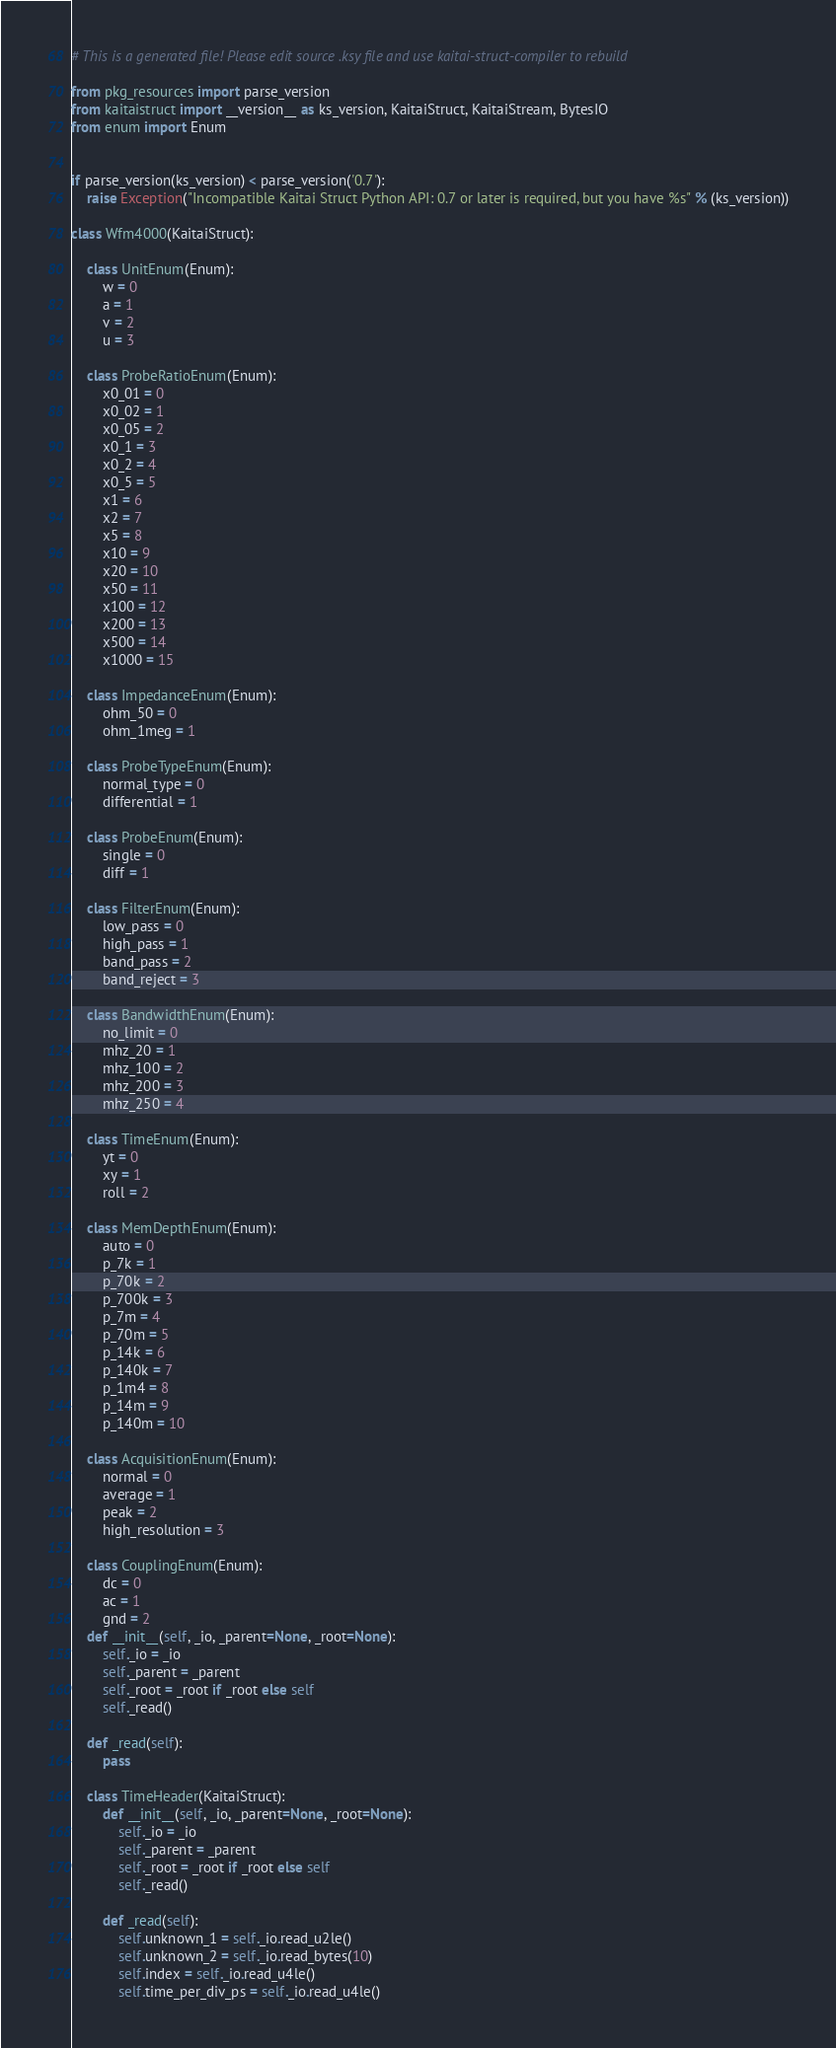<code> <loc_0><loc_0><loc_500><loc_500><_Python_># This is a generated file! Please edit source .ksy file and use kaitai-struct-compiler to rebuild

from pkg_resources import parse_version
from kaitaistruct import __version__ as ks_version, KaitaiStruct, KaitaiStream, BytesIO
from enum import Enum


if parse_version(ks_version) < parse_version('0.7'):
    raise Exception("Incompatible Kaitai Struct Python API: 0.7 or later is required, but you have %s" % (ks_version))

class Wfm4000(KaitaiStruct):

    class UnitEnum(Enum):
        w = 0
        a = 1
        v = 2
        u = 3

    class ProbeRatioEnum(Enum):
        x0_01 = 0
        x0_02 = 1
        x0_05 = 2
        x0_1 = 3
        x0_2 = 4
        x0_5 = 5
        x1 = 6
        x2 = 7
        x5 = 8
        x10 = 9
        x20 = 10
        x50 = 11
        x100 = 12
        x200 = 13
        x500 = 14
        x1000 = 15

    class ImpedanceEnum(Enum):
        ohm_50 = 0
        ohm_1meg = 1

    class ProbeTypeEnum(Enum):
        normal_type = 0
        differential = 1

    class ProbeEnum(Enum):
        single = 0
        diff = 1

    class FilterEnum(Enum):
        low_pass = 0
        high_pass = 1
        band_pass = 2
        band_reject = 3

    class BandwidthEnum(Enum):
        no_limit = 0
        mhz_20 = 1
        mhz_100 = 2
        mhz_200 = 3
        mhz_250 = 4

    class TimeEnum(Enum):
        yt = 0
        xy = 1
        roll = 2

    class MemDepthEnum(Enum):
        auto = 0
        p_7k = 1
        p_70k = 2
        p_700k = 3
        p_7m = 4
        p_70m = 5
        p_14k = 6
        p_140k = 7
        p_1m4 = 8
        p_14m = 9
        p_140m = 10

    class AcquisitionEnum(Enum):
        normal = 0
        average = 1
        peak = 2
        high_resolution = 3

    class CouplingEnum(Enum):
        dc = 0
        ac = 1
        gnd = 2
    def __init__(self, _io, _parent=None, _root=None):
        self._io = _io
        self._parent = _parent
        self._root = _root if _root else self
        self._read()

    def _read(self):
        pass

    class TimeHeader(KaitaiStruct):
        def __init__(self, _io, _parent=None, _root=None):
            self._io = _io
            self._parent = _parent
            self._root = _root if _root else self
            self._read()

        def _read(self):
            self.unknown_1 = self._io.read_u2le()
            self.unknown_2 = self._io.read_bytes(10)
            self.index = self._io.read_u4le()
            self.time_per_div_ps = self._io.read_u4le()</code> 